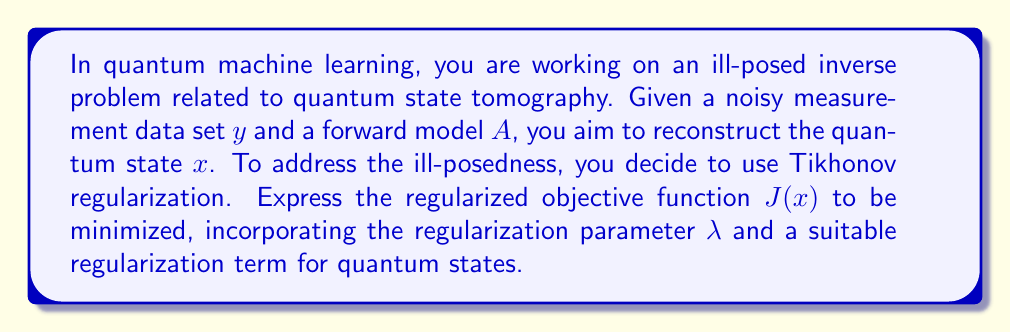Teach me how to tackle this problem. To solve this problem, we'll follow these steps:

1) Recall the general form of Tikhonov regularization:
   $$J(x) = \|Ax - y\|^2 + \lambda R(x)$$
   where $R(x)$ is the regularization term.

2) For quantum states, we need a regularization term that preserves the properties of density matrices. A suitable choice is the Frobenius norm of the state:
   $$R(x) = \|x\|_F^2 = \text{Tr}(x^{\dagger}x)$$

3) Incorporating this into the objective function:
   $$J(x) = \|Ax - y\|^2 + \lambda \text{Tr}(x^{\dagger}x)$$

4) Expand the first term:
   $$J(x) = (Ax - y)^{\dagger}(Ax - y) + \lambda \text{Tr}(x^{\dagger}x)$$

5) The final regularized objective function to be minimized is:
   $$J(x) = x^{\dagger}A^{\dagger}Ax - y^{\dagger}Ax - x^{\dagger}A^{\dagger}y + y^{\dagger}y + \lambda \text{Tr}(x^{\dagger}x)$$

This objective function balances the fidelity to the measured data with the regularization term, which helps to stabilize the solution and enforce the properties of quantum states.
Answer: $$J(x) = x^{\dagger}A^{\dagger}Ax - y^{\dagger}Ax - x^{\dagger}A^{\dagger}y + y^{\dagger}y + \lambda \text{Tr}(x^{\dagger}x)$$ 